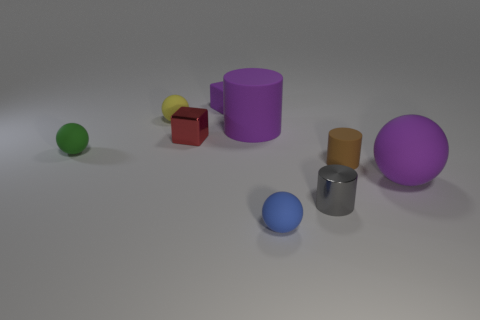How many rubber objects are blue objects or tiny cubes?
Your answer should be compact. 2. Are there any blue cubes of the same size as the purple rubber cube?
Your response must be concise. No. Is the number of tiny red metallic things in front of the gray metallic object greater than the number of tiny rubber spheres?
Offer a terse response. No. What number of big objects are either metal things or red metal things?
Your answer should be very brief. 0. How many tiny purple things have the same shape as the small brown thing?
Your answer should be compact. 0. There is a big purple object that is in front of the rubber cylinder in front of the green thing; what is its material?
Make the answer very short. Rubber. There is a metallic thing behind the purple ball; how big is it?
Your response must be concise. Small. How many purple objects are large things or matte objects?
Your response must be concise. 3. Are there any other things that are made of the same material as the tiny red cube?
Give a very brief answer. Yes. What is the material of the big object that is the same shape as the tiny yellow rubber thing?
Your answer should be compact. Rubber. 